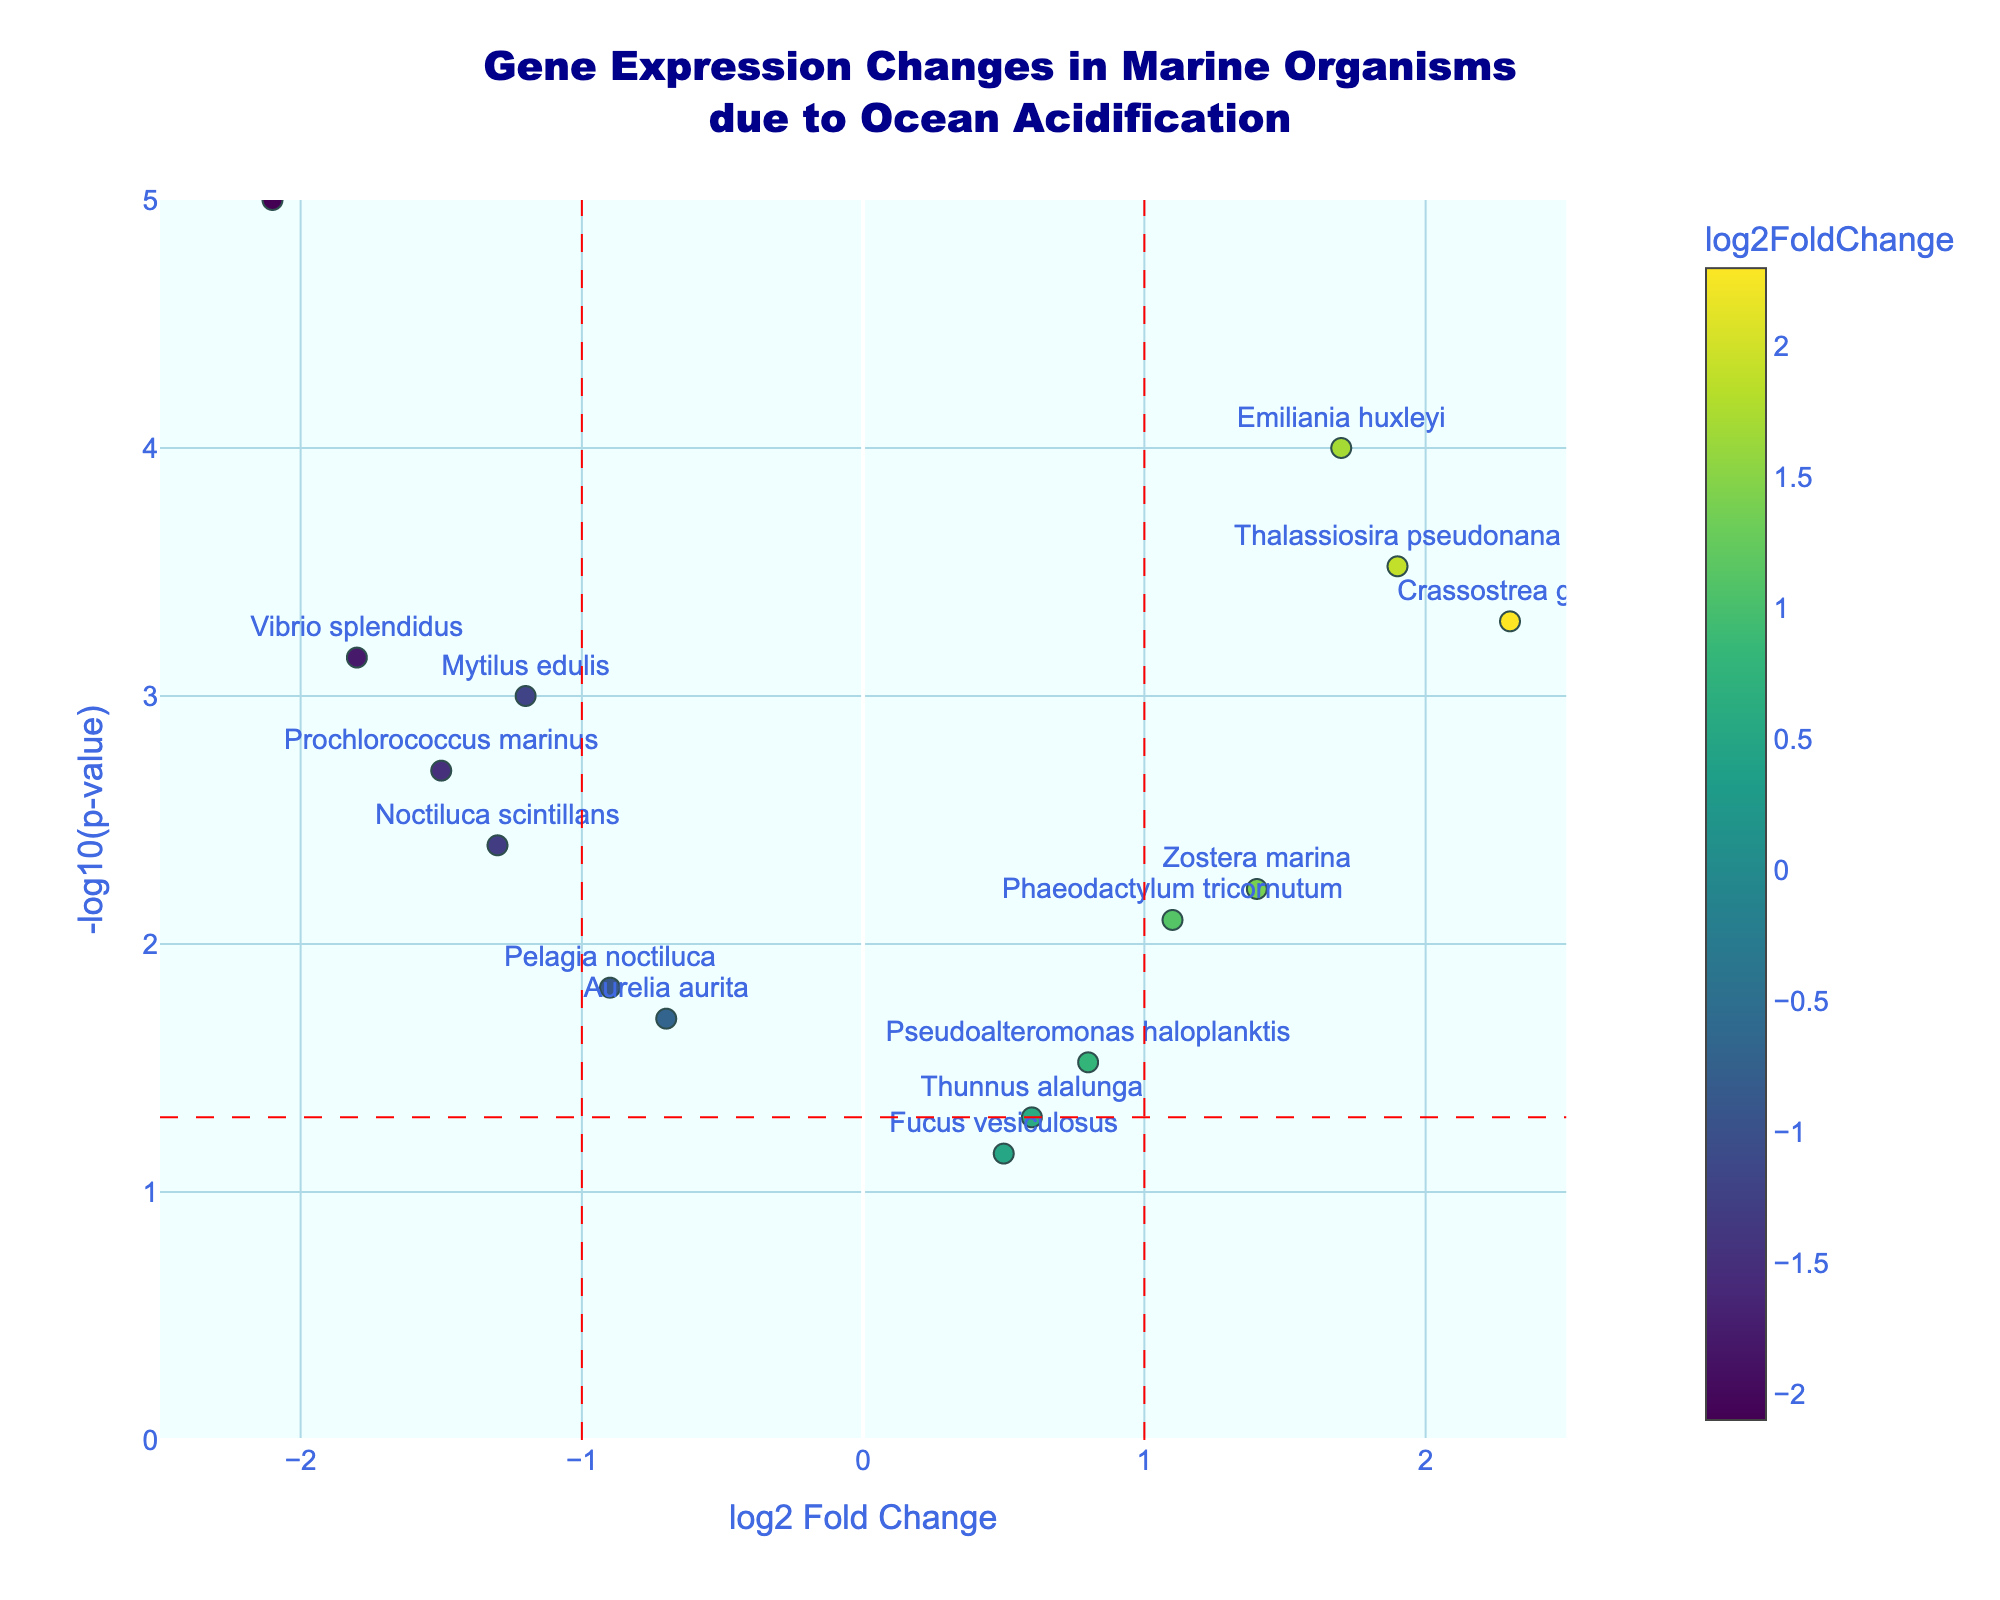How many genes have an increased expression due to ocean acidification? To determine this, we count data points with a log2 Fold Change (x-axis) greater than 0. These points indicate increased gene expression.
Answer: 7 Which gene exhibits the highest p-value? In a Volcano Plot, the p-value is shown on the y-axis as -log10(p-value), so the gene with the lowest point on the y-axis indicates the highest p-value.
Answer: Thunnus alalunga How many genes have a significant change in expression, defined as p-value less than 0.05? The horizontal red dashed line marks the -log10(0.05) threshold. Counting the points above this line gives the number of genes with significant changes.
Answer: 10 Which gene has the highest fold increase in expression? The gene with the maximal log2 Fold Change on the positive side of the x-axis shows the greatest fold increase.
Answer: Crassostrea gigas Which gene has the most significant reduction in expression? The gene with the lowest log2 Fold Change on the negative side of the x-axis shows the greatest reduction in expression.
Answer: Posidonia oceanica How does the expression level of Emiliania huxleyi compare to Mytilus edulis? Identify their positions on the x-axis. Emiliania huxleyi has a positive log2 Fold Change indicating increased expression, while Mytilus edulis has a negative log2 Fold Change indicating reduced expression.
Answer: Emiliania huxleyi shows increased expression, and Mytilus edulis shows reduced expression What is the p-value for Prochlorococcus marinus? Locate Prochlorococcus marinus on the plot and observe the y-axis coordinate, which is -log10(p-value). Use this value to calculate the p-value. The y-coordinate for Prochlorococcus marinus is approximately 2.5, so p-value = 10^-2.5.
Answer: 0.0032 How many genes show more than a 1.5 fold decrease in expression? Count data points with a log2 Fold Change less than -1.5.
Answer: 2 Which genes are close to the significance threshold at p-value = 0.05? Identify points near the horizontal red dashed line at -log10(0.05). These genes are close to this threshold.
Answer: Phaeodactylum tricornutum and Pelagia noctiluca What color represents the highest log2 Fold Change on the plot? The color scale (colorbar) to the side shows the color representation of log2 Fold Changes. The highest log2 Fold Change is represented by the brightest (yellowish) color.
Answer: Yellow 